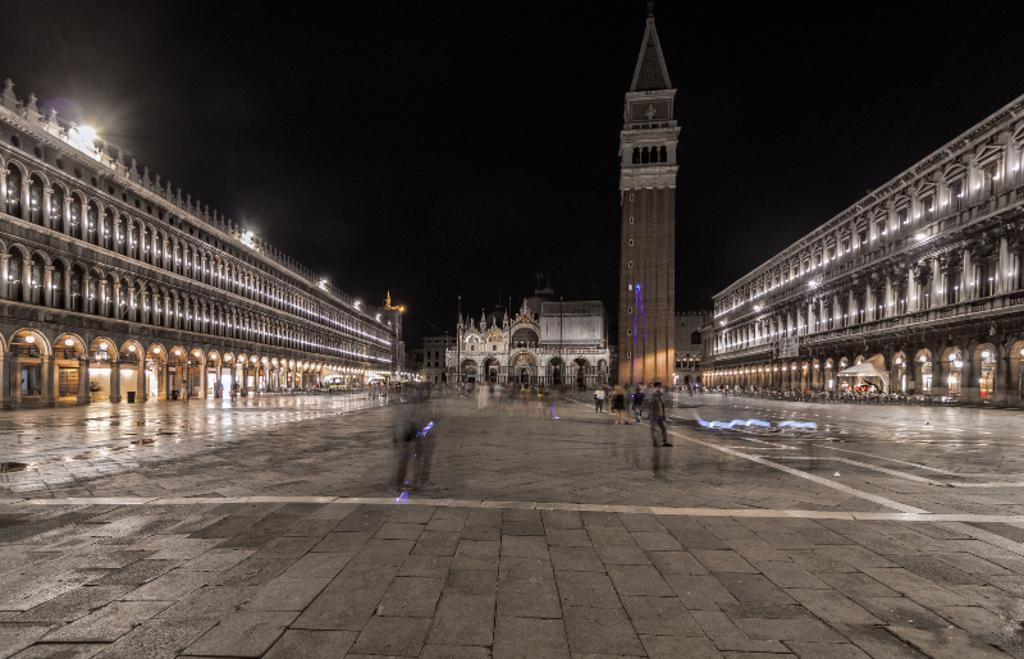Could you give a brief overview of what you see in this image? In this picture we can see buildings, there is a tower in the middle, we can also see some people in the middle, on the left side and right side there are some lights, we can see the sky at the top of the picture. 